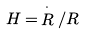<formula> <loc_0><loc_0><loc_500><loc_500>H = \, \stackrel { \cdot } { R } / R</formula> 